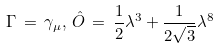Convert formula to latex. <formula><loc_0><loc_0><loc_500><loc_500>\Gamma \, = \, \gamma _ { \mu } , \, \hat { O } \, = \, \frac { 1 } { 2 } \lambda ^ { 3 } + \frac { 1 } { 2 \sqrt { 3 } } \lambda ^ { 8 }</formula> 